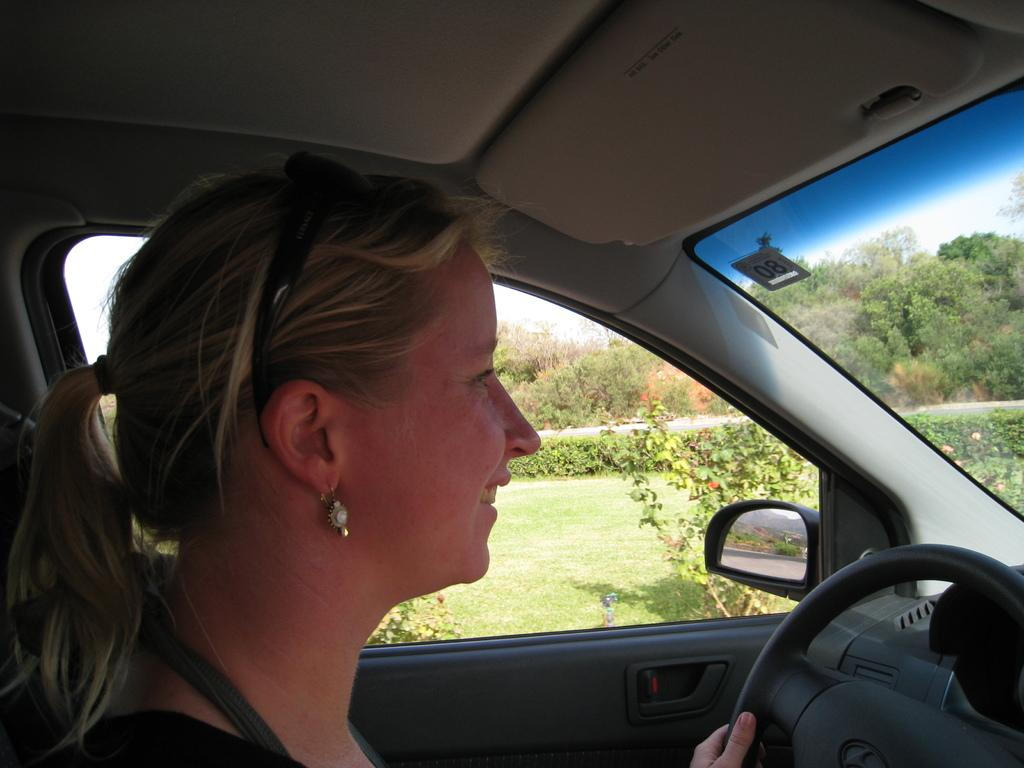Who is present in the image? There is a woman in the image. What is the woman doing in the image? The woman is sitting inside a car and smiling. What is the woman holding in the image? The woman is holding the steering wheel. What can be seen through the window in the image? There are planets and trees visible through the window. What is the aftermath of the car accident in the image? There is no car accident present in the image, and therefore no aftermath can be observed. What is the friction between the car and the road in the image? The image does not show the car in motion or in contact with the road, so it is not possible to determine the friction between the car and the road. 